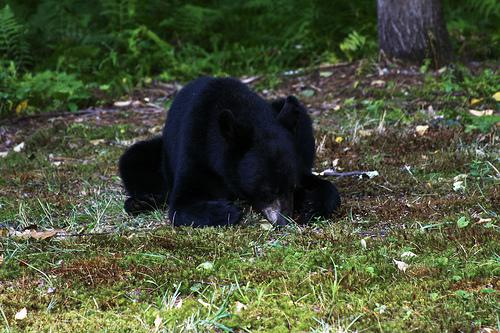Question: what color is the animal?
Choices:
A. Black.
B. White.
C. Brown.
D. Red.
Answer with the letter. Answer: A Question: who is in the picture?
Choices:
A. A family.
B. A baseball team.
C. No one.
D. 3 children.
Answer with the letter. Answer: C Question: how many tree trunks do you see?
Choices:
A. 2.
B. 1.
C. 3.
D. 4.
Answer with the letter. Answer: B Question: what color is the foliage?
Choices:
A. Yellow.
B. Red.
C. Green.
D. Brown.
Answer with the letter. Answer: C 